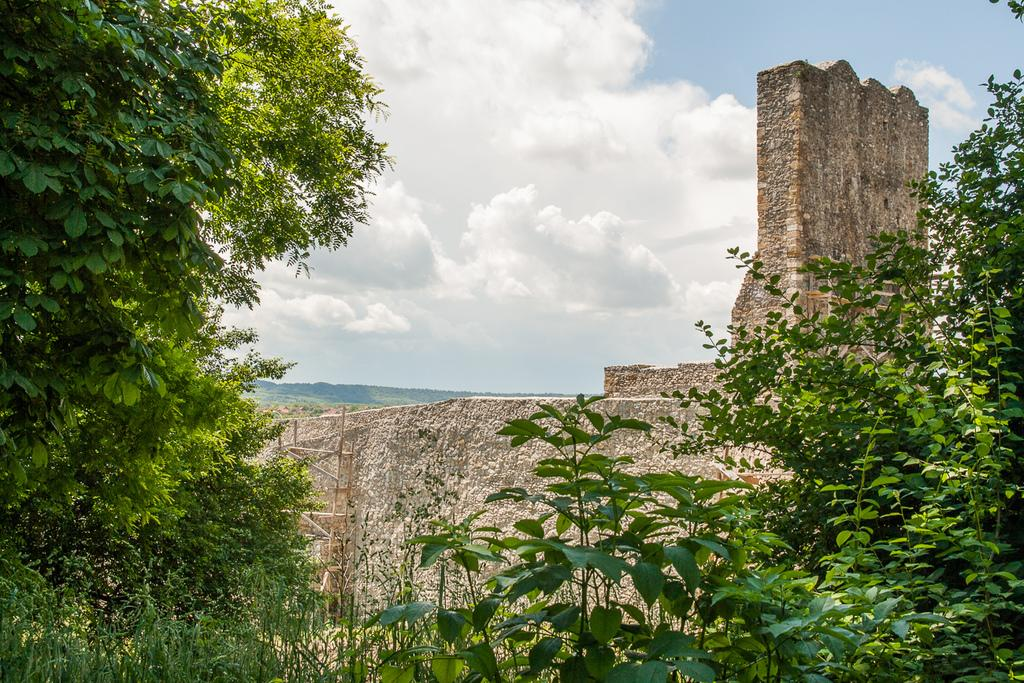What type of vegetation can be seen in the image? There are plants and trees in the image. What structure is visible in the image? There is a wall in the image. What is visible in the background of the image? The sky is visible in the background of the image. How would you describe the sky in the image? The sky has heavy clouds in the image. What type of music can be heard coming from the cattle in the image? There are no cattle present in the image, so it is not possible to determine what, if any, music might be heard. 